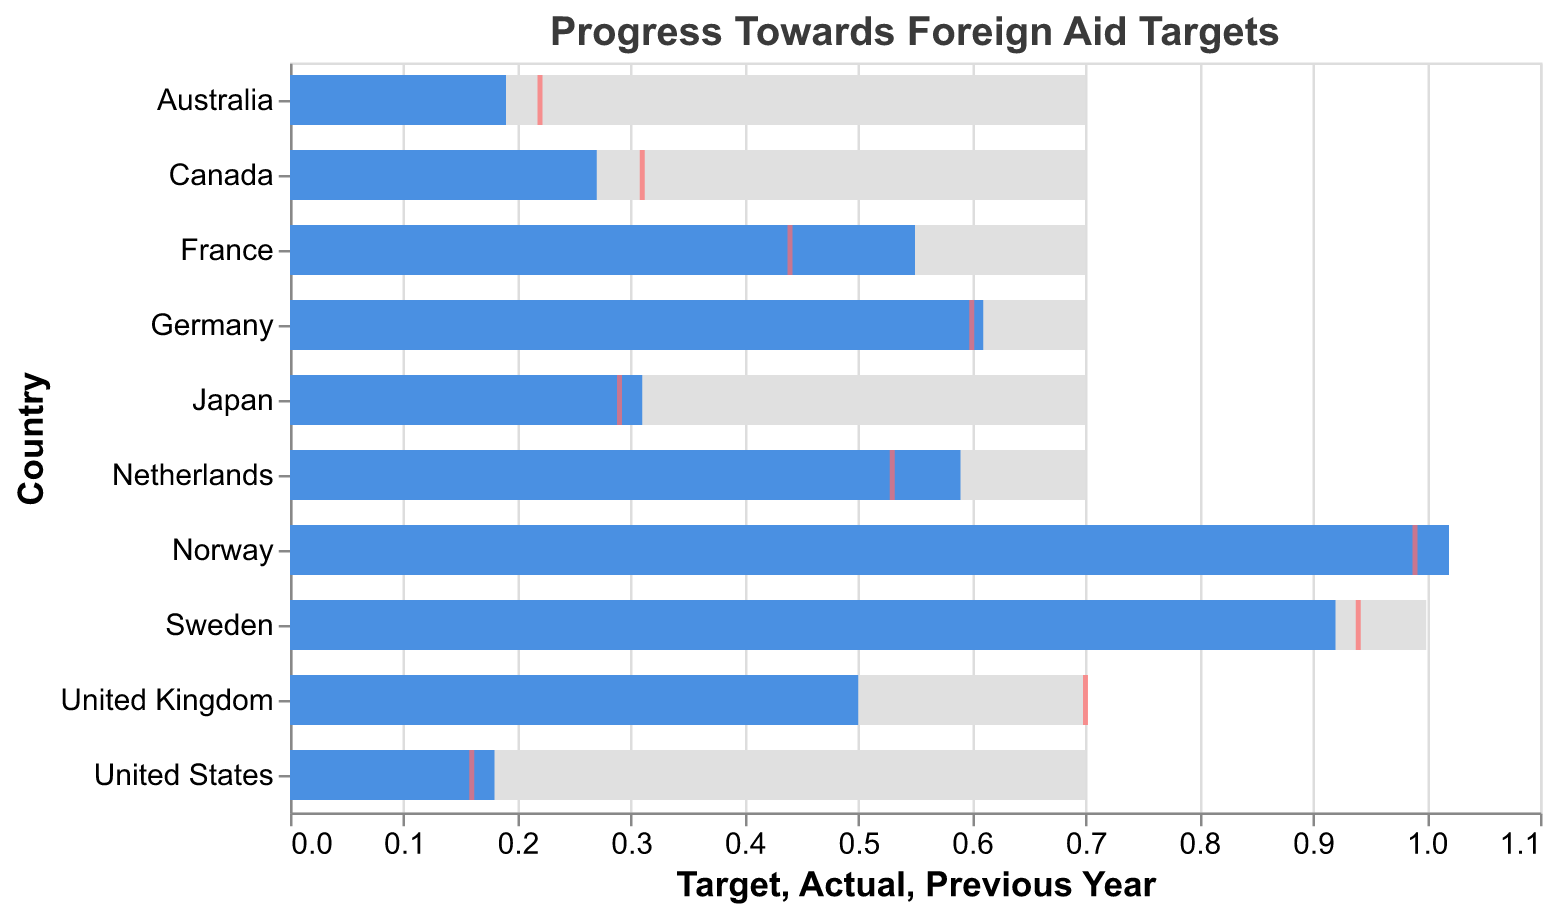What's the title of the bullet chart? The title is displayed prominently at the top of the chart.
Answer: Progress Towards Foreign Aid Targets Which country has surpassed its foreign aid target? By examining the bullet chart, we can see that the bar representing the actual value exceeds the target line.
Answer: Norway What was the actual foreign aid contribution of France in the previous year? The tick mark in red represents the previous year's value. For France, it is at 0.44.
Answer: 0.44 How does the actual aid contribution of the United Kingdom compare to its previous year's contribution? The actual (blue bar) is 0.5 and the previous year's aid (red tick) is 0.7. The actual contribution is lower than the previous year's contribution.
Answer: Lower Which country has the smallest actual foreign aid contribution in the current year? By looking at the height of the blue bars, we can identify the smallest one.
Answer: United States What is the difference between the target and actual foreign aid contribution for Japan? The target is 0.7 and the actual contribution is 0.31. The difference is 0.7 - 0.31.
Answer: 0.39 Among the listed countries, which one has the highest actual foreign aid contribution in terms of percentage of GNI? By examining the blue bars, the country with the highest actual contribution can be identified.
Answer: Norway Is there any country whose actual foreign aid contribution has decreased compared to the previous year? Checking where the blue bar (actual) is lower than the red tick (previous year) for each country.
Answer: Canada & Australia What is the collective target percentage for foreign aid of the identified countries (sum of all targets)? Sum up the target values for all listed countries.
Answer: 7.7 